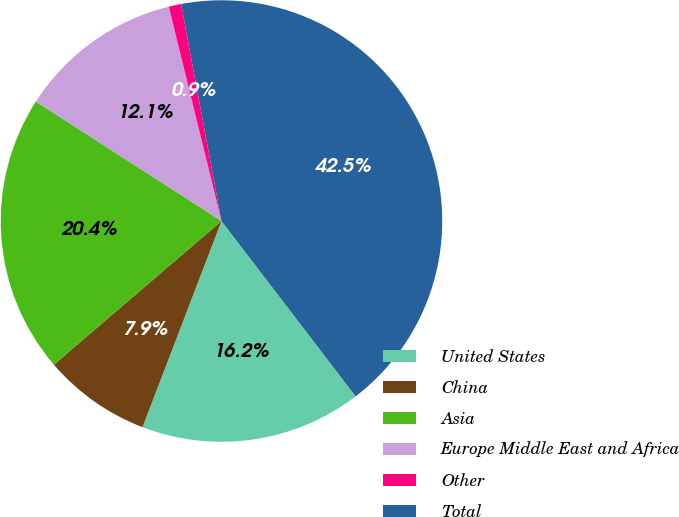Convert chart to OTSL. <chart><loc_0><loc_0><loc_500><loc_500><pie_chart><fcel>United States<fcel>China<fcel>Asia<fcel>Europe Middle East and Africa<fcel>Other<fcel>Total<nl><fcel>16.22%<fcel>7.9%<fcel>20.38%<fcel>12.06%<fcel>0.91%<fcel>42.53%<nl></chart> 